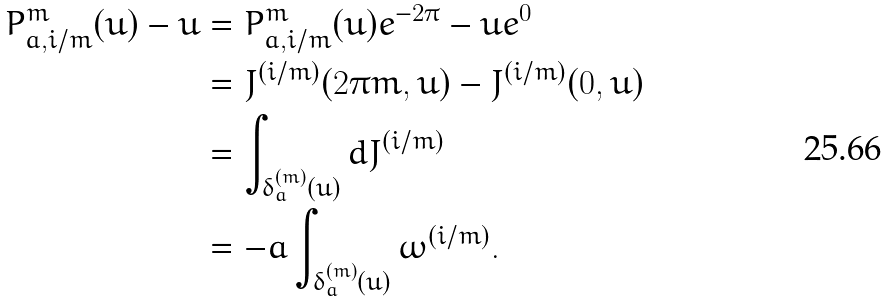Convert formula to latex. <formula><loc_0><loc_0><loc_500><loc_500>P ^ { m } _ { a , i / m } ( u ) - u & = P ^ { m } _ { a , i / m } ( u ) e ^ { - 2 \pi } - u e ^ { 0 } \\ & = J ^ { ( { i } / { m } ) } ( 2 \pi m , u ) - J ^ { ( { i } / { m } ) } ( 0 , u ) \\ & = \int _ { \delta _ { a } ^ { ( m ) } ( u ) } d J ^ { ( { i } / { m } ) } \\ & = - a \int _ { \delta _ { a } ^ { ( m ) } ( u ) } \omega ^ { ( { i } / { m } ) } .</formula> 